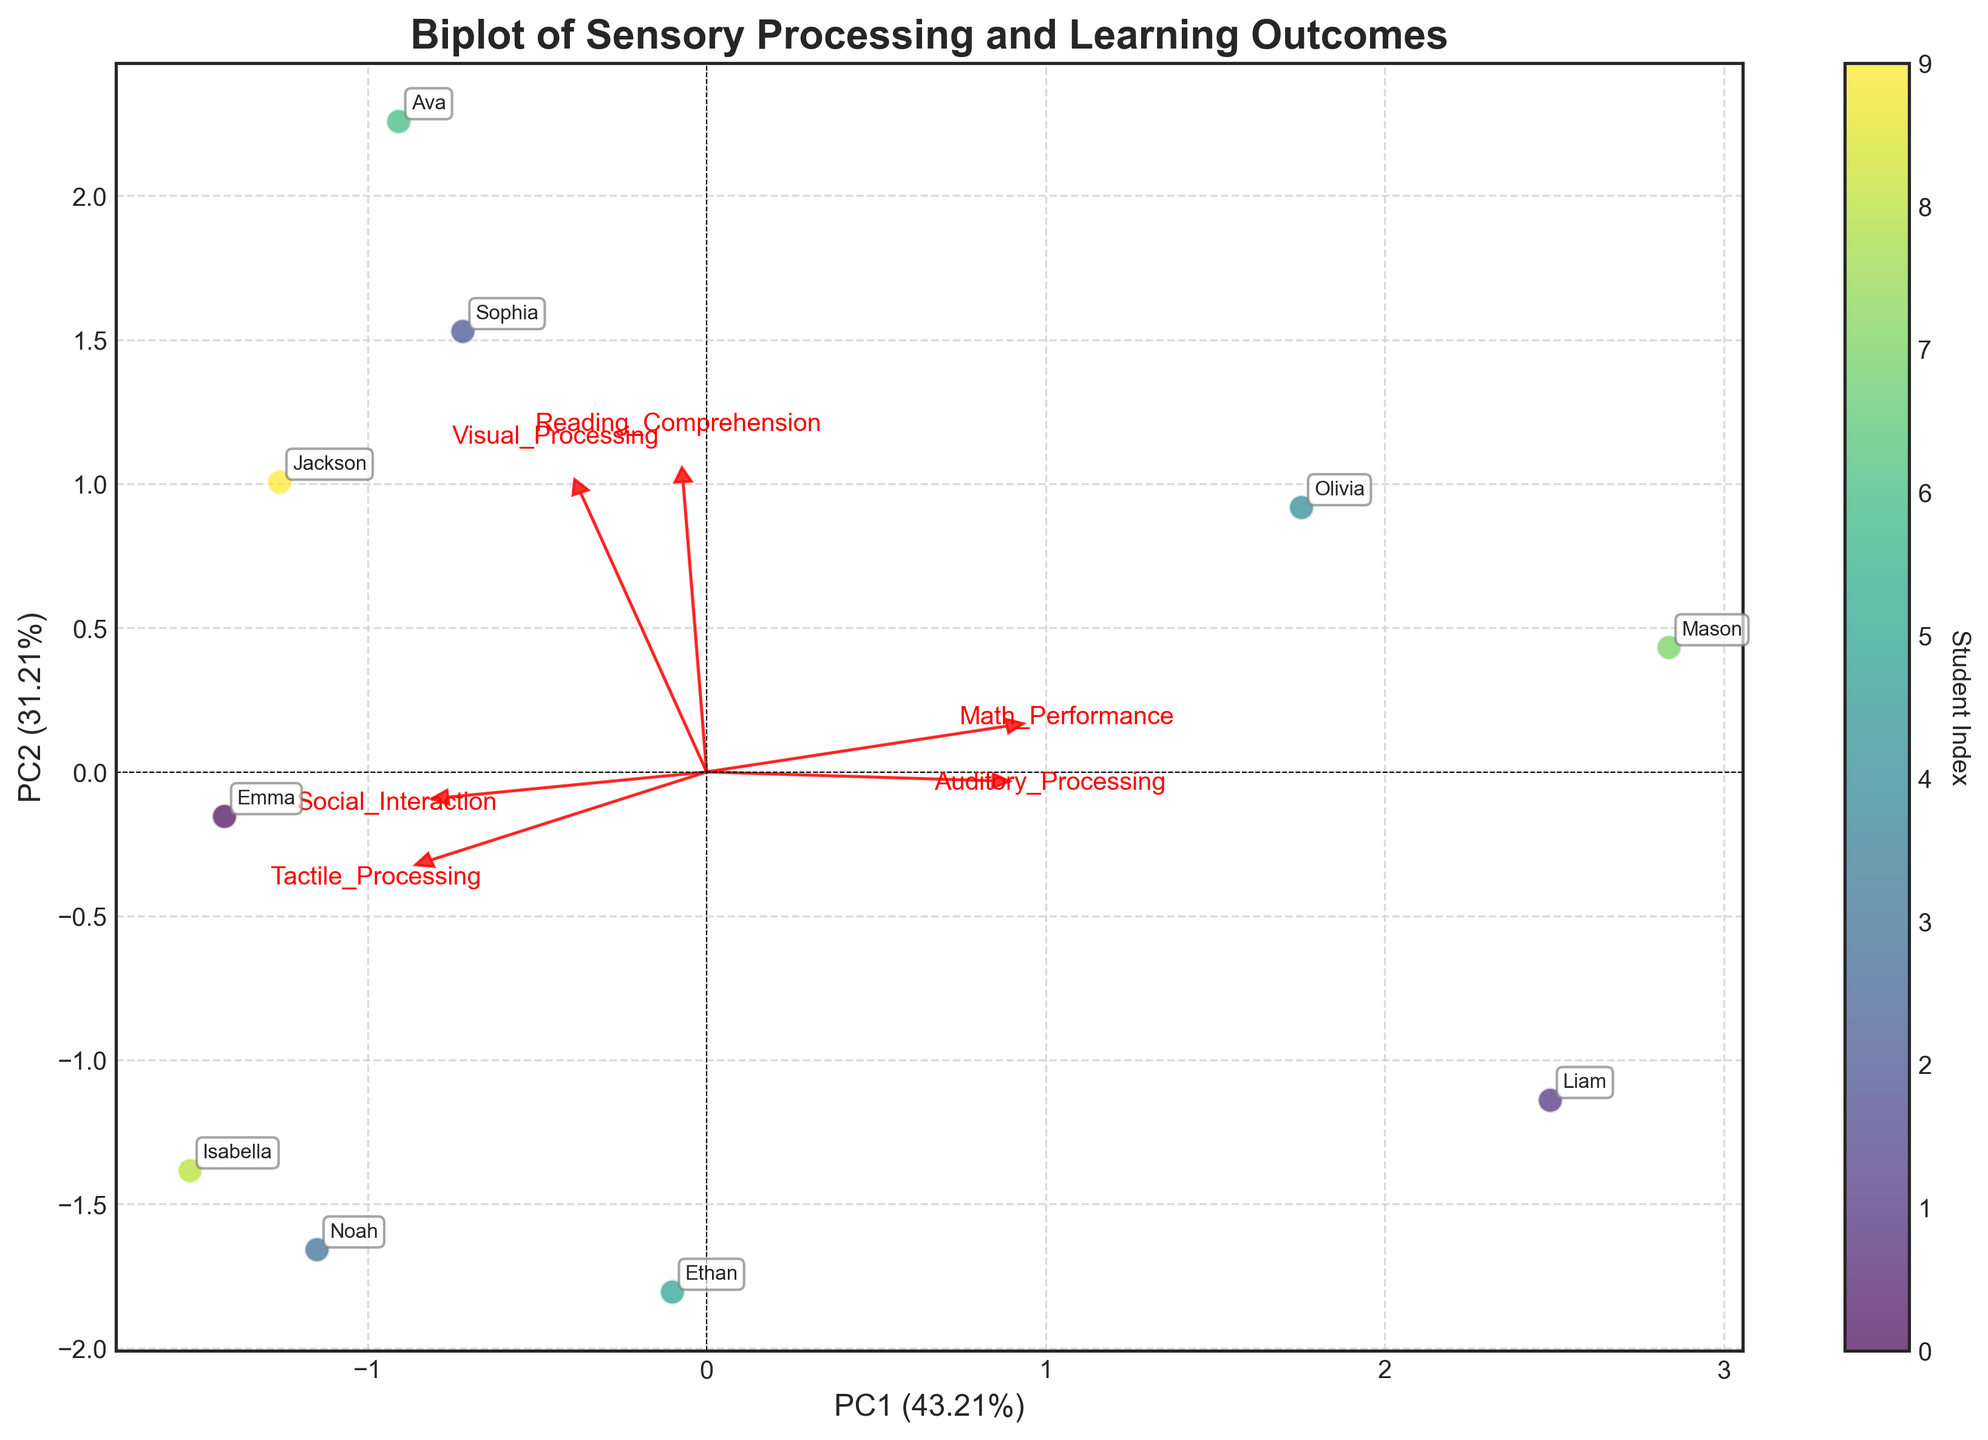What is the title of the biplot? The title of the plot is displayed at the top center of the figure. It is a text element that describes the main subject of the plot.
Answer: Biplot of Sensory Processing and Learning Outcomes How many eigenvectors are plotted? Eigenvectors are represented as arrows originating from the center of the plot. Count the number of arrows.
Answer: 6 Which student has the highest Reading Comprehension score? Look for the student labels and their respective positions in the plot. Identify the label near the point that aligns with high Reading Comprehension indicated by eigenvector direction.
Answer: Ava Describe the general relationship between Math Performance and Tactile Processing. Observe the direction and relative lengths of the eigenvectors for Math Performance and Tactile Processing. Determine if they point in similar, opposite, or orthogonal directions.
Answer: Positively related Who is positioned farthest from the origin, and what might this indicate? Identify the data point furthest from the origin by measuring distance in the plot. This indicates the student whose sensory processing and learning outcomes deviate most from the average.
Answer: Olivia What percentage of the variance is explained by the first principal component (PC1)? Examine the x-axis label, which typically includes the explained variance percentage of PC1.
Answer: 42% Which sensory processing dimension is least associated with Social Interaction? Look at the eigenvectors for each sensory processing dimension and compare their alignment with the Social Interaction eigenvector. The dimension with the least alignment is the least associated.
Answer: Tactile Processing Are there any students with similar sensory processing patterns and learning outcomes? Identify any closely clustered points, which represent students with similar profiles. Note their labels to determine the students.
Answer: Emma and Jackson What is the relative contribution of Auditory Processing to the first principal component compared to Visual Processing? Compare the lengths of the eigenvector arrows for Auditory Processing and Visual Processing projected onto the first principal component.
Answer: Visual Processing contributes more 